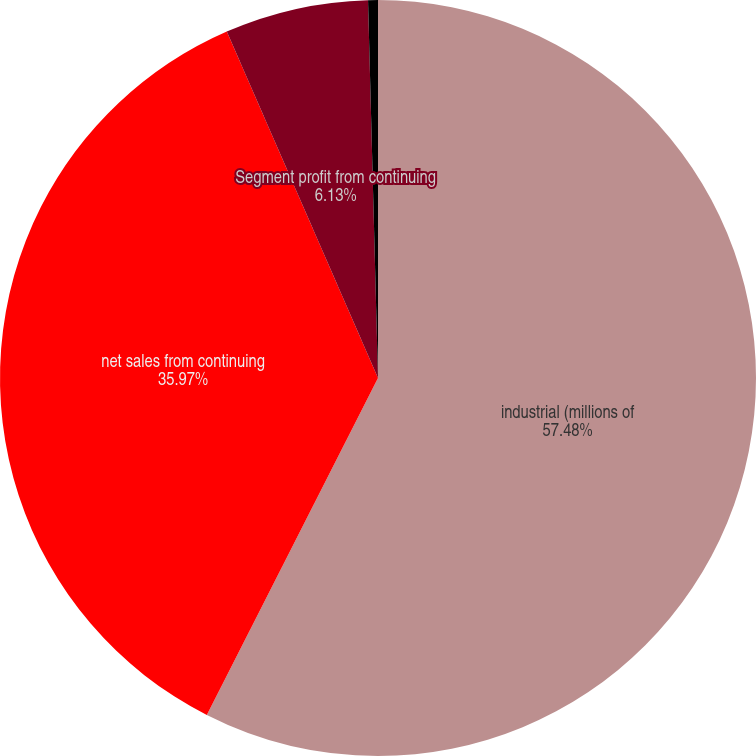Convert chart. <chart><loc_0><loc_0><loc_500><loc_500><pie_chart><fcel>industrial (millions of<fcel>net sales from continuing<fcel>Segment profit from continuing<fcel>of net sales<nl><fcel>57.48%<fcel>35.97%<fcel>6.13%<fcel>0.42%<nl></chart> 